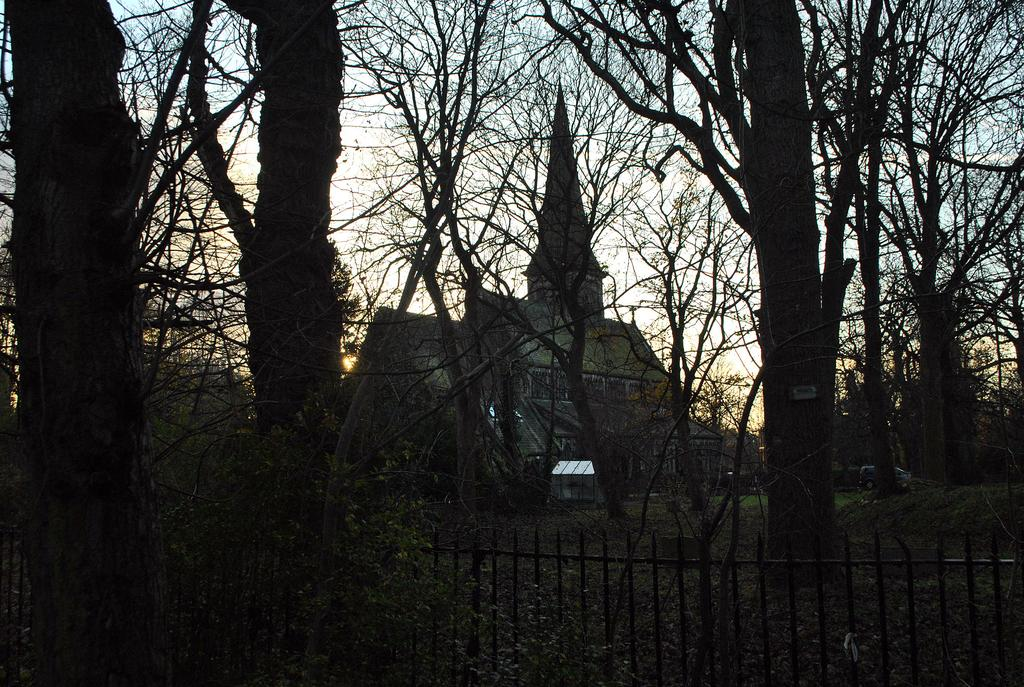What type of structure is present in the picture? There is a house in the picture. What type of natural elements can be seen in the picture? There are trees and plants in the picture. What type of architectural feature is present in the picture? There is a grille in the picture. What type of transportation is present in the picture? There is a vehicle in the picture. What part of the natural environment is visible in the picture? The sky is visible in the picture. How many boats are visible in the picture? There are no boats present in the picture. What type of board is being used in the picture? There is no board present in the picture. 